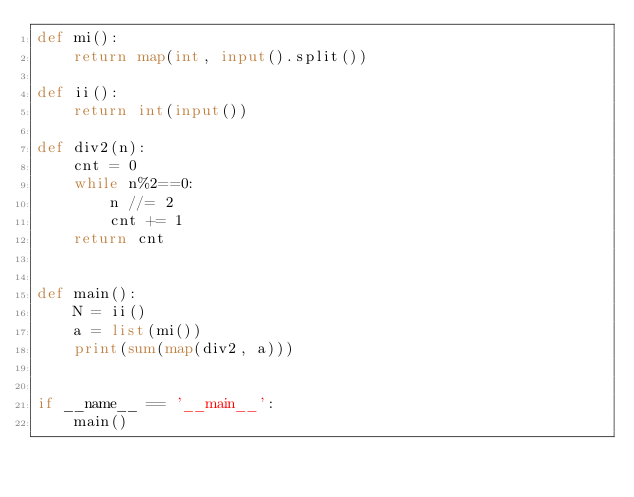Convert code to text. <code><loc_0><loc_0><loc_500><loc_500><_Python_>def mi():
    return map(int, input().split())

def ii():
    return int(input())

def div2(n):
    cnt = 0
    while n%2==0:
        n //= 2
        cnt += 1
    return cnt


def main():
    N = ii()
    a = list(mi())
    print(sum(map(div2, a)))


if __name__ == '__main__':
    main()</code> 